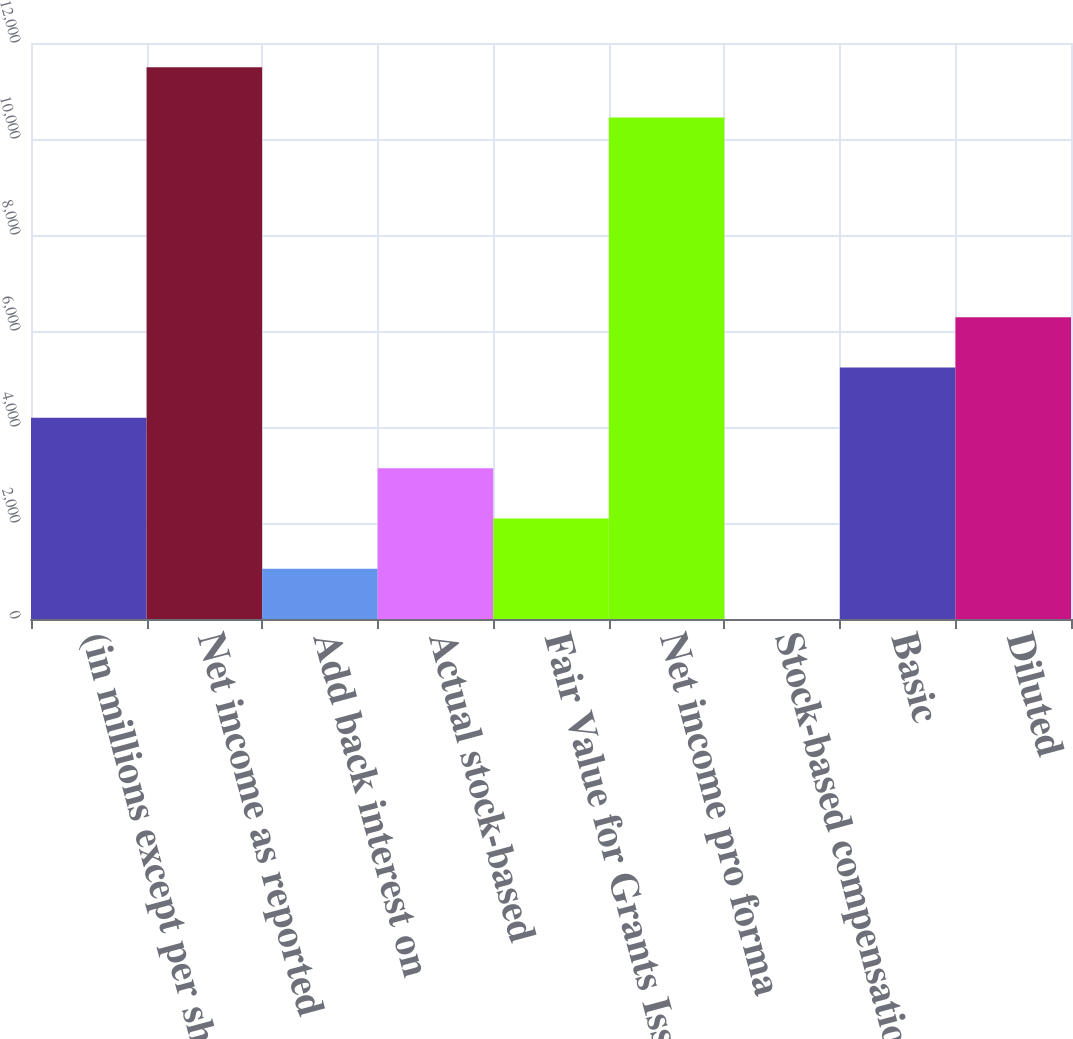Convert chart to OTSL. <chart><loc_0><loc_0><loc_500><loc_500><bar_chart><fcel>(in millions except per share<fcel>Net income as reported<fcel>Add back interest on<fcel>Actual stock-based<fcel>Fair Value for Grants Issued<fcel>Net income pro forma<fcel>Stock-based compensation net<fcel>Basic<fcel>Diluted<nl><fcel>4190.81<fcel>11496.7<fcel>1047.71<fcel>3143.11<fcel>2095.41<fcel>10449<fcel>0.01<fcel>5238.51<fcel>6286.21<nl></chart> 